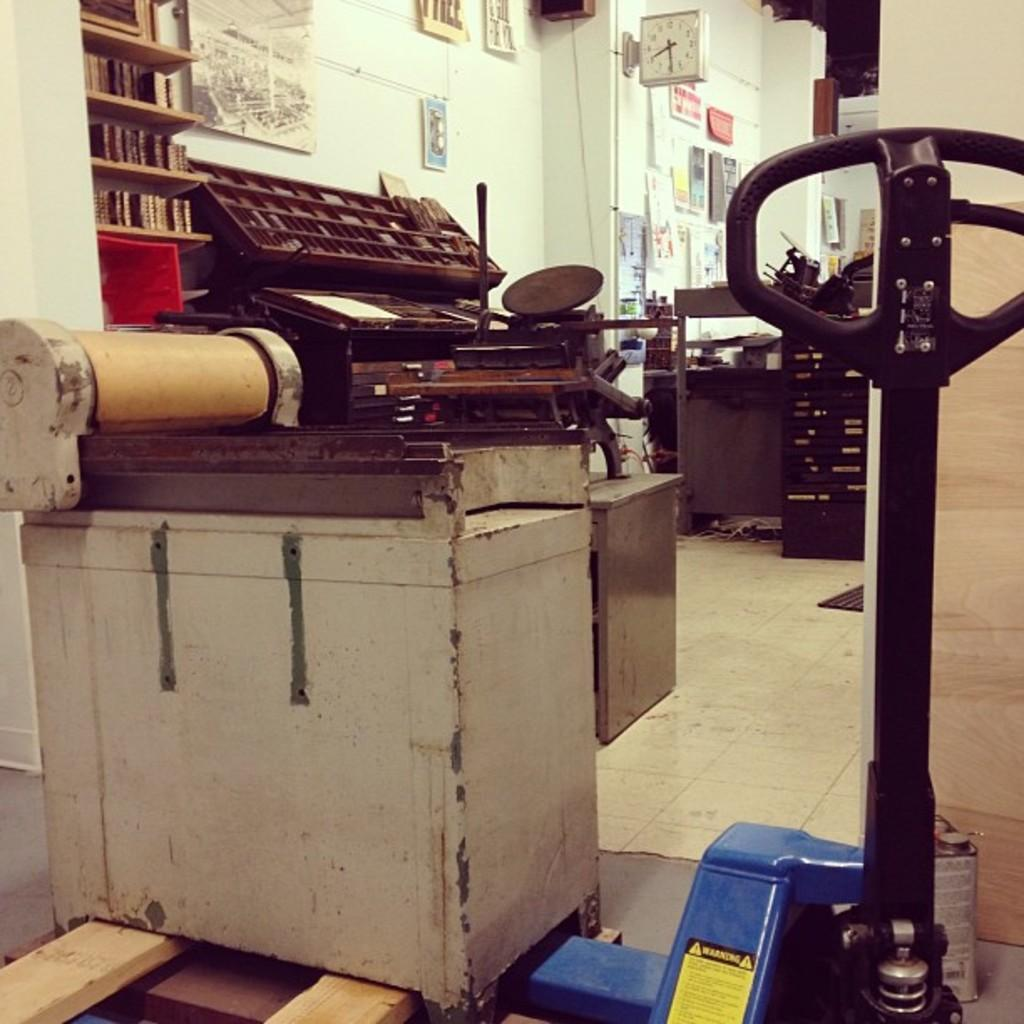What type of objects can be seen in the image? There are machines in the image. What else can be found in the image besides the machines? There are books in the racks and a clock in the background of the image. Are there any documents or notes visible in the image? Yes, there are papers attached to the wall in the background of the image. What color is the wall in the image? The wall is white in color. How many sisters are present in the image? There are no sisters present in the image; it features machines, books, a clock, papers, and a white wall. 